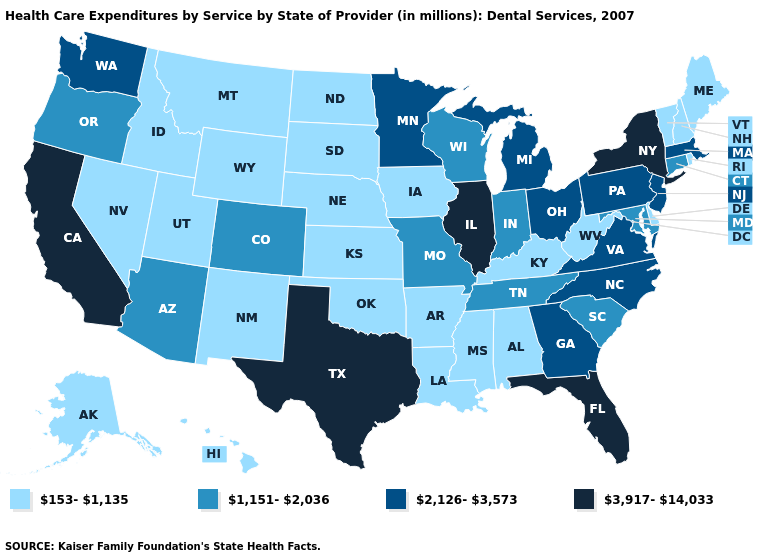Name the states that have a value in the range 1,151-2,036?
Be succinct. Arizona, Colorado, Connecticut, Indiana, Maryland, Missouri, Oregon, South Carolina, Tennessee, Wisconsin. Does Vermont have the lowest value in the USA?
Concise answer only. Yes. Which states have the lowest value in the USA?
Short answer required. Alabama, Alaska, Arkansas, Delaware, Hawaii, Idaho, Iowa, Kansas, Kentucky, Louisiana, Maine, Mississippi, Montana, Nebraska, Nevada, New Hampshire, New Mexico, North Dakota, Oklahoma, Rhode Island, South Dakota, Utah, Vermont, West Virginia, Wyoming. Does the map have missing data?
Give a very brief answer. No. Name the states that have a value in the range 3,917-14,033?
Be succinct. California, Florida, Illinois, New York, Texas. What is the value of Ohio?
Write a very short answer. 2,126-3,573. Among the states that border New Hampshire , which have the lowest value?
Quick response, please. Maine, Vermont. Name the states that have a value in the range 1,151-2,036?
Concise answer only. Arizona, Colorado, Connecticut, Indiana, Maryland, Missouri, Oregon, South Carolina, Tennessee, Wisconsin. Name the states that have a value in the range 2,126-3,573?
Be succinct. Georgia, Massachusetts, Michigan, Minnesota, New Jersey, North Carolina, Ohio, Pennsylvania, Virginia, Washington. Does Alaska have the same value as Montana?
Answer briefly. Yes. What is the value of Louisiana?
Keep it brief. 153-1,135. Among the states that border North Dakota , does Minnesota have the lowest value?
Concise answer only. No. Which states have the lowest value in the USA?
Concise answer only. Alabama, Alaska, Arkansas, Delaware, Hawaii, Idaho, Iowa, Kansas, Kentucky, Louisiana, Maine, Mississippi, Montana, Nebraska, Nevada, New Hampshire, New Mexico, North Dakota, Oklahoma, Rhode Island, South Dakota, Utah, Vermont, West Virginia, Wyoming. What is the value of South Dakota?
Give a very brief answer. 153-1,135. 